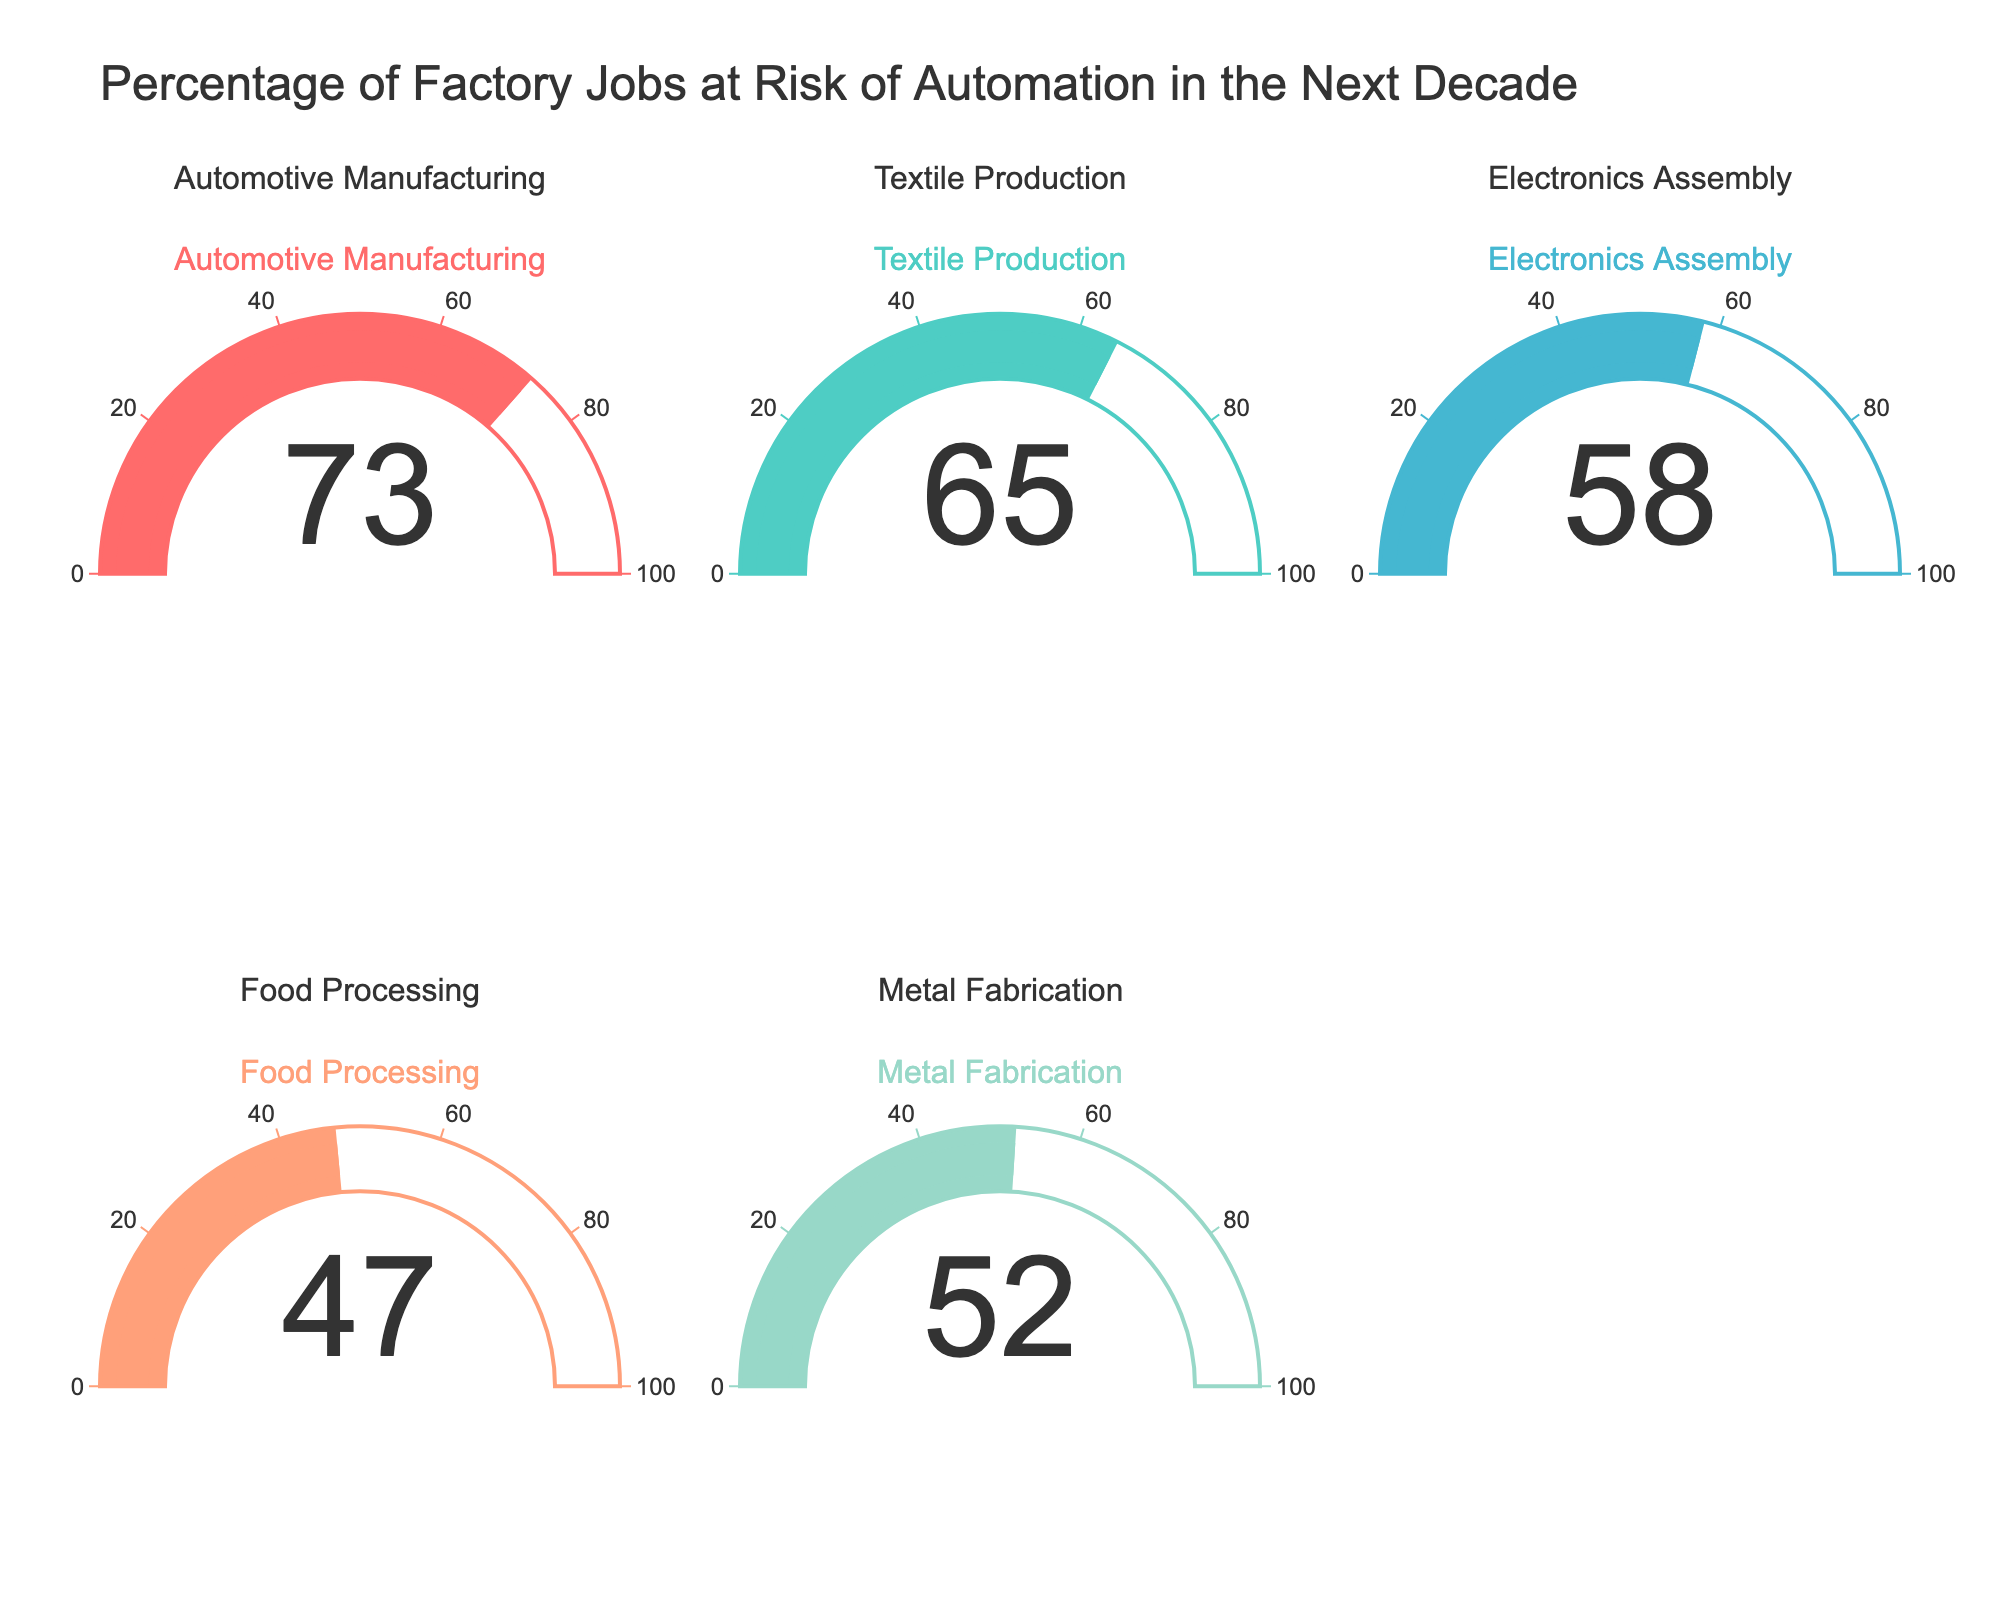what's the title of the figure? The title is placed at the top of the figure, usually in larger font size. It provides a description of what the figure is about.
Answer: Percentage of Factory Jobs at Risk of Automation in the Next Decade what is the automation risk percentage for Textile Production? Identify the gauge associated with Textile Production and read the value shown in the center.
Answer: 65 which industry has the highest automation risk percentage? Compare the values shown in the center of each gauge to find the largest one. The highest percentage is marked with a color-coded area in the gauge.
Answer: Automotive Manufacturing which industry has the lowest automation risk percentage? Compare the values shown in the center of each gauge to find the smallest one. The lowest percentage is marked with a color-coded area in the gauge.
Answer: Food Processing what's the average automation risk percentage across all industries? Add up all the risk percentages and divide by the number of industries: (73 + 65 + 58 + 47 + 52) / 5 = 59
Answer: 59 how much higher is the automation risk percentage for Metal Fabrication compared to Food Processing? Subtract the value for Food Processing from the value for Metal Fabrication: 52 - 47 = 5
Answer: 5 percentage points if you combine the automation risks of Textile Production and Electronics Assembly, what is the total? Sum the values of both industries: 65 + 58 = 123
Answer: 123 which industry has a risk percentage close to 50% and what is it? Look for gauges with percentages around 50 and identify the corresponding industry.
Answer: Metal Fabrication, 52 how many industries have an automation risk percentage above the overall average? Calculate the average risk percentage, identify which values are above it, and count those industries: The average is 59, Automotive Manufacturing (73), and Textile Production (65) are above it.
Answer: 2 industries what’s the color of the bar used in the gauge for Electronics Assembly? Each gauge uses a unique color for its bar, often matching the title text color.
Answer: Light Blue 